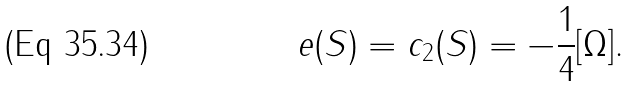Convert formula to latex. <formula><loc_0><loc_0><loc_500><loc_500>e ( S ) = c _ { 2 } ( S ) = - \frac { 1 } { 4 } [ \Omega ] .</formula> 